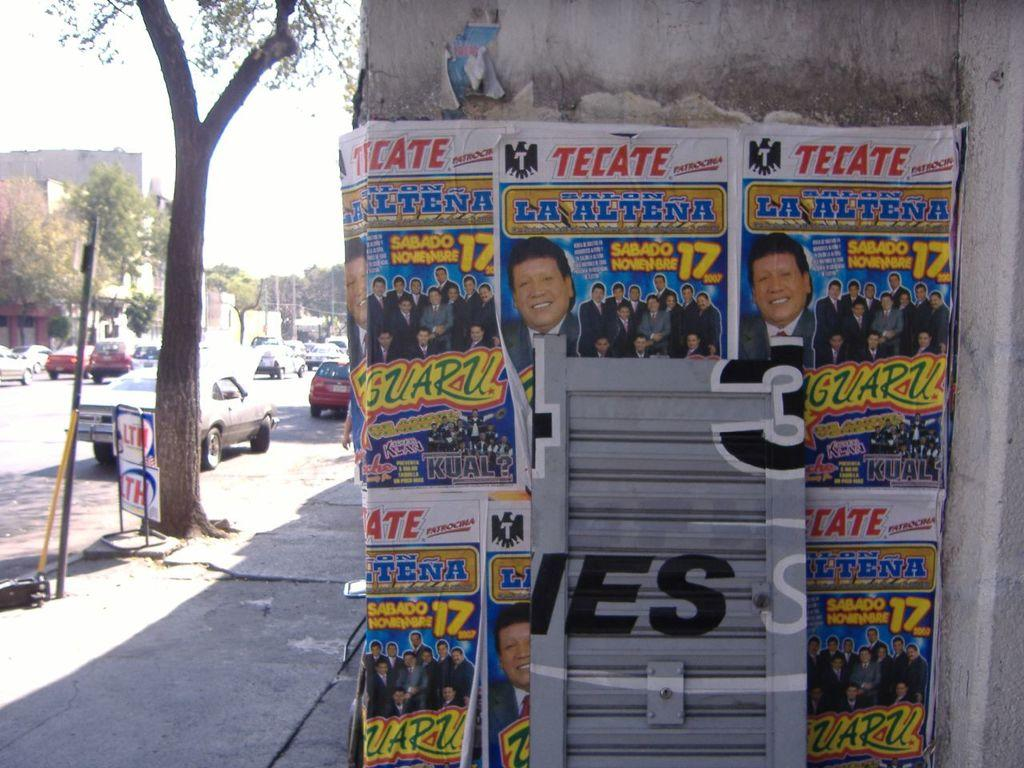What type of vehicles can be seen in the image? There are cars in the image. What other objects are present in the image besides cars? There are poles, trees, a building, and a poster on the wall of the building in the image. Where are the trees located in the image? The trees are on the left side of the image. What is the condition of the sky in the image? The sky is clear in the image. How many crayons are scattered on the ground in the image? There are no crayons present in the image. Can you describe the crowd gathered around the cars in the image? There is no crowd present in the image; it only shows cars, poles, trees, a building, and a poster on the wall of the building. 